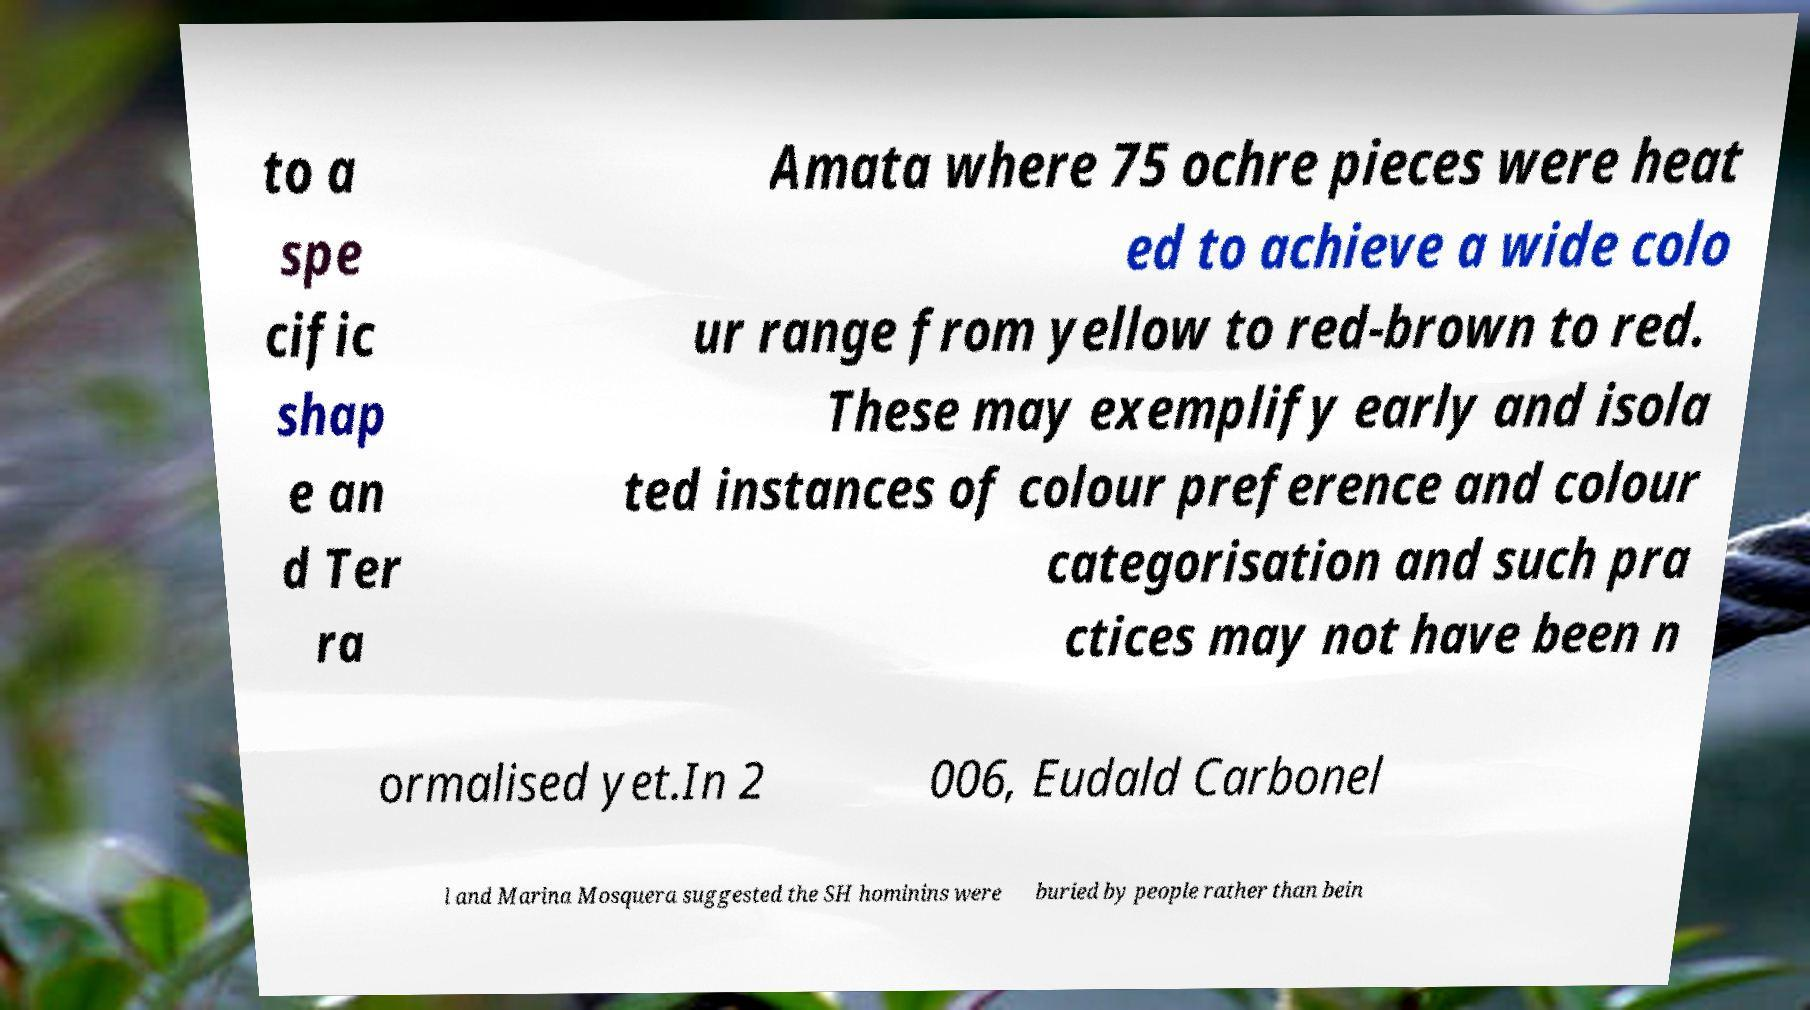For documentation purposes, I need the text within this image transcribed. Could you provide that? to a spe cific shap e an d Ter ra Amata where 75 ochre pieces were heat ed to achieve a wide colo ur range from yellow to red-brown to red. These may exemplify early and isola ted instances of colour preference and colour categorisation and such pra ctices may not have been n ormalised yet.In 2 006, Eudald Carbonel l and Marina Mosquera suggested the SH hominins were buried by people rather than bein 